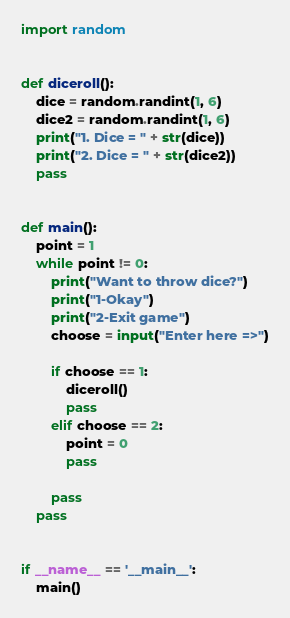<code> <loc_0><loc_0><loc_500><loc_500><_Python_>import random


def diceroll():
    dice = random.randint(1, 6)
    dice2 = random.randint(1, 6)
    print("1. Dice = " + str(dice))
    print("2. Dice = " + str(dice2))
    pass


def main():
    point = 1
    while point != 0:
        print("Want to throw dice?")
        print("1-Okay")
        print("2-Exit game")
        choose = input("Enter here =>")

        if choose == 1:
            diceroll()
            pass
        elif choose == 2:
            point = 0
            pass

        pass
    pass


if __name__ == '__main__':
    main()
</code> 